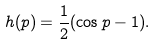Convert formula to latex. <formula><loc_0><loc_0><loc_500><loc_500>h ( p ) = \frac { 1 } { 2 } ( \cos p - 1 ) .</formula> 